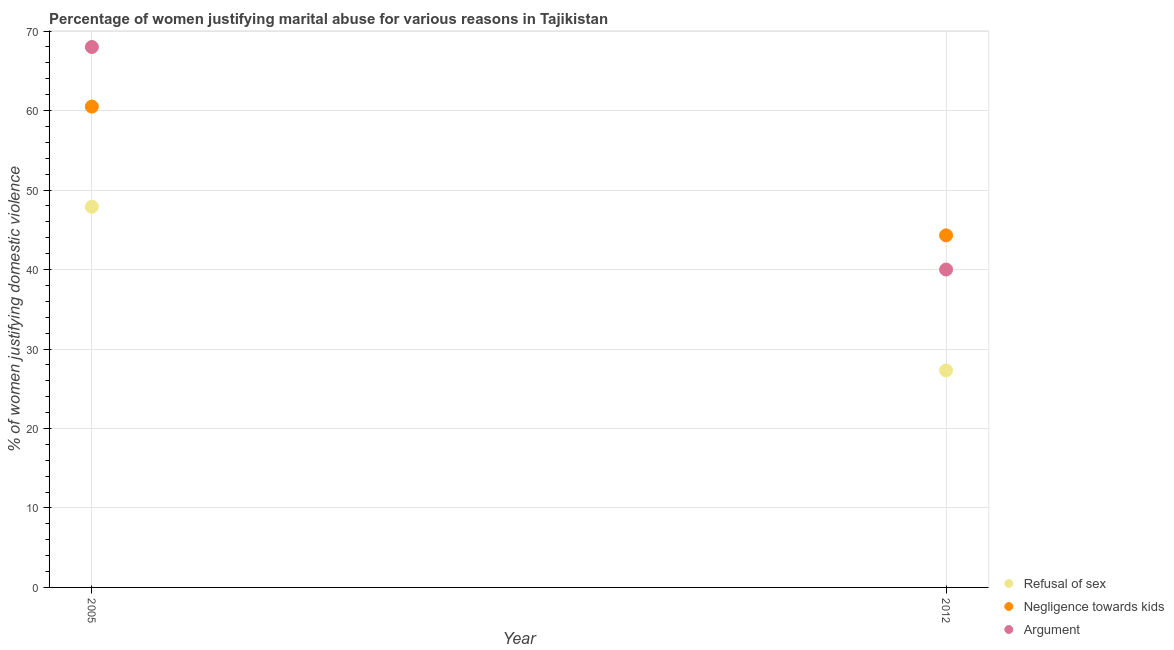What is the percentage of women justifying domestic violence due to negligence towards kids in 2005?
Give a very brief answer. 60.5. Across all years, what is the maximum percentage of women justifying domestic violence due to arguments?
Give a very brief answer. 68. Across all years, what is the minimum percentage of women justifying domestic violence due to arguments?
Ensure brevity in your answer.  40. In which year was the percentage of women justifying domestic violence due to negligence towards kids minimum?
Offer a very short reply. 2012. What is the total percentage of women justifying domestic violence due to negligence towards kids in the graph?
Give a very brief answer. 104.8. What is the difference between the percentage of women justifying domestic violence due to negligence towards kids in 2005 and that in 2012?
Make the answer very short. 16.2. What is the difference between the percentage of women justifying domestic violence due to refusal of sex in 2012 and the percentage of women justifying domestic violence due to arguments in 2005?
Offer a terse response. -40.7. What is the average percentage of women justifying domestic violence due to negligence towards kids per year?
Offer a very short reply. 52.4. In the year 2012, what is the difference between the percentage of women justifying domestic violence due to refusal of sex and percentage of women justifying domestic violence due to negligence towards kids?
Provide a succinct answer. -17. What is the ratio of the percentage of women justifying domestic violence due to arguments in 2005 to that in 2012?
Offer a terse response. 1.7. In how many years, is the percentage of women justifying domestic violence due to negligence towards kids greater than the average percentage of women justifying domestic violence due to negligence towards kids taken over all years?
Ensure brevity in your answer.  1. Is it the case that in every year, the sum of the percentage of women justifying domestic violence due to refusal of sex and percentage of women justifying domestic violence due to negligence towards kids is greater than the percentage of women justifying domestic violence due to arguments?
Offer a terse response. Yes. Does the percentage of women justifying domestic violence due to refusal of sex monotonically increase over the years?
Your answer should be compact. No. Is the percentage of women justifying domestic violence due to arguments strictly greater than the percentage of women justifying domestic violence due to refusal of sex over the years?
Your answer should be very brief. Yes. Is the percentage of women justifying domestic violence due to refusal of sex strictly less than the percentage of women justifying domestic violence due to negligence towards kids over the years?
Your response must be concise. Yes. How many dotlines are there?
Offer a very short reply. 3. What is the difference between two consecutive major ticks on the Y-axis?
Give a very brief answer. 10. Are the values on the major ticks of Y-axis written in scientific E-notation?
Offer a very short reply. No. Does the graph contain any zero values?
Offer a very short reply. No. Does the graph contain grids?
Your response must be concise. Yes. Where does the legend appear in the graph?
Ensure brevity in your answer.  Bottom right. How many legend labels are there?
Provide a succinct answer. 3. How are the legend labels stacked?
Your response must be concise. Vertical. What is the title of the graph?
Provide a succinct answer. Percentage of women justifying marital abuse for various reasons in Tajikistan. What is the label or title of the Y-axis?
Offer a terse response. % of women justifying domestic violence. What is the % of women justifying domestic violence in Refusal of sex in 2005?
Make the answer very short. 47.9. What is the % of women justifying domestic violence in Negligence towards kids in 2005?
Provide a succinct answer. 60.5. What is the % of women justifying domestic violence of Refusal of sex in 2012?
Your response must be concise. 27.3. What is the % of women justifying domestic violence in Negligence towards kids in 2012?
Provide a short and direct response. 44.3. What is the % of women justifying domestic violence of Argument in 2012?
Your answer should be very brief. 40. Across all years, what is the maximum % of women justifying domestic violence in Refusal of sex?
Ensure brevity in your answer.  47.9. Across all years, what is the maximum % of women justifying domestic violence of Negligence towards kids?
Ensure brevity in your answer.  60.5. Across all years, what is the minimum % of women justifying domestic violence of Refusal of sex?
Your answer should be compact. 27.3. Across all years, what is the minimum % of women justifying domestic violence in Negligence towards kids?
Give a very brief answer. 44.3. What is the total % of women justifying domestic violence of Refusal of sex in the graph?
Ensure brevity in your answer.  75.2. What is the total % of women justifying domestic violence of Negligence towards kids in the graph?
Your answer should be very brief. 104.8. What is the total % of women justifying domestic violence in Argument in the graph?
Give a very brief answer. 108. What is the difference between the % of women justifying domestic violence in Refusal of sex in 2005 and that in 2012?
Provide a short and direct response. 20.6. What is the difference between the % of women justifying domestic violence of Negligence towards kids in 2005 and that in 2012?
Offer a very short reply. 16.2. What is the difference between the % of women justifying domestic violence of Argument in 2005 and that in 2012?
Make the answer very short. 28. What is the difference between the % of women justifying domestic violence in Refusal of sex in 2005 and the % of women justifying domestic violence in Argument in 2012?
Your response must be concise. 7.9. What is the difference between the % of women justifying domestic violence of Negligence towards kids in 2005 and the % of women justifying domestic violence of Argument in 2012?
Make the answer very short. 20.5. What is the average % of women justifying domestic violence in Refusal of sex per year?
Provide a succinct answer. 37.6. What is the average % of women justifying domestic violence of Negligence towards kids per year?
Provide a succinct answer. 52.4. What is the average % of women justifying domestic violence in Argument per year?
Offer a very short reply. 54. In the year 2005, what is the difference between the % of women justifying domestic violence of Refusal of sex and % of women justifying domestic violence of Negligence towards kids?
Ensure brevity in your answer.  -12.6. In the year 2005, what is the difference between the % of women justifying domestic violence in Refusal of sex and % of women justifying domestic violence in Argument?
Your answer should be very brief. -20.1. In the year 2012, what is the difference between the % of women justifying domestic violence of Negligence towards kids and % of women justifying domestic violence of Argument?
Offer a very short reply. 4.3. What is the ratio of the % of women justifying domestic violence in Refusal of sex in 2005 to that in 2012?
Provide a short and direct response. 1.75. What is the ratio of the % of women justifying domestic violence of Negligence towards kids in 2005 to that in 2012?
Your response must be concise. 1.37. What is the difference between the highest and the second highest % of women justifying domestic violence of Refusal of sex?
Make the answer very short. 20.6. What is the difference between the highest and the lowest % of women justifying domestic violence in Refusal of sex?
Provide a succinct answer. 20.6. 